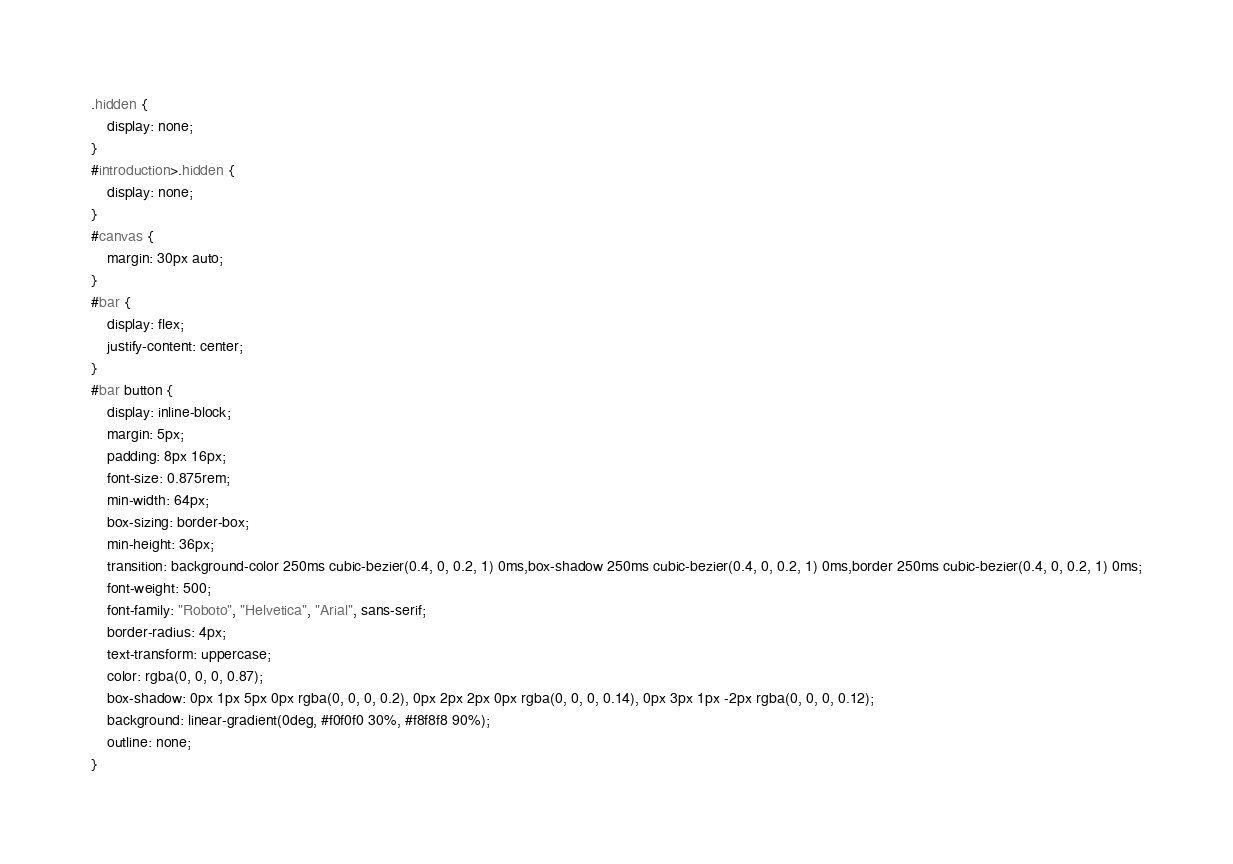<code> <loc_0><loc_0><loc_500><loc_500><_CSS_>.hidden {
    display: none;
}
#introduction>.hidden {
    display: none;
}
#canvas {
    margin: 30px auto;
}
#bar {
    display: flex;
    justify-content: center;
}
#bar button {
    display: inline-block;
    margin: 5px;
    padding: 8px 16px;
    font-size: 0.875rem;
    min-width: 64px;
    box-sizing: border-box;
    min-height: 36px;
    transition: background-color 250ms cubic-bezier(0.4, 0, 0.2, 1) 0ms,box-shadow 250ms cubic-bezier(0.4, 0, 0.2, 1) 0ms,border 250ms cubic-bezier(0.4, 0, 0.2, 1) 0ms;
    font-weight: 500;
    font-family: "Roboto", "Helvetica", "Arial", sans-serif;
    border-radius: 4px;
    text-transform: uppercase;
    color: rgba(0, 0, 0, 0.87);
    box-shadow: 0px 1px 5px 0px rgba(0, 0, 0, 0.2), 0px 2px 2px 0px rgba(0, 0, 0, 0.14), 0px 3px 1px -2px rgba(0, 0, 0, 0.12);
    background: linear-gradient(0deg, #f0f0f0 30%, #f8f8f8 90%);
    outline: none;
}</code> 